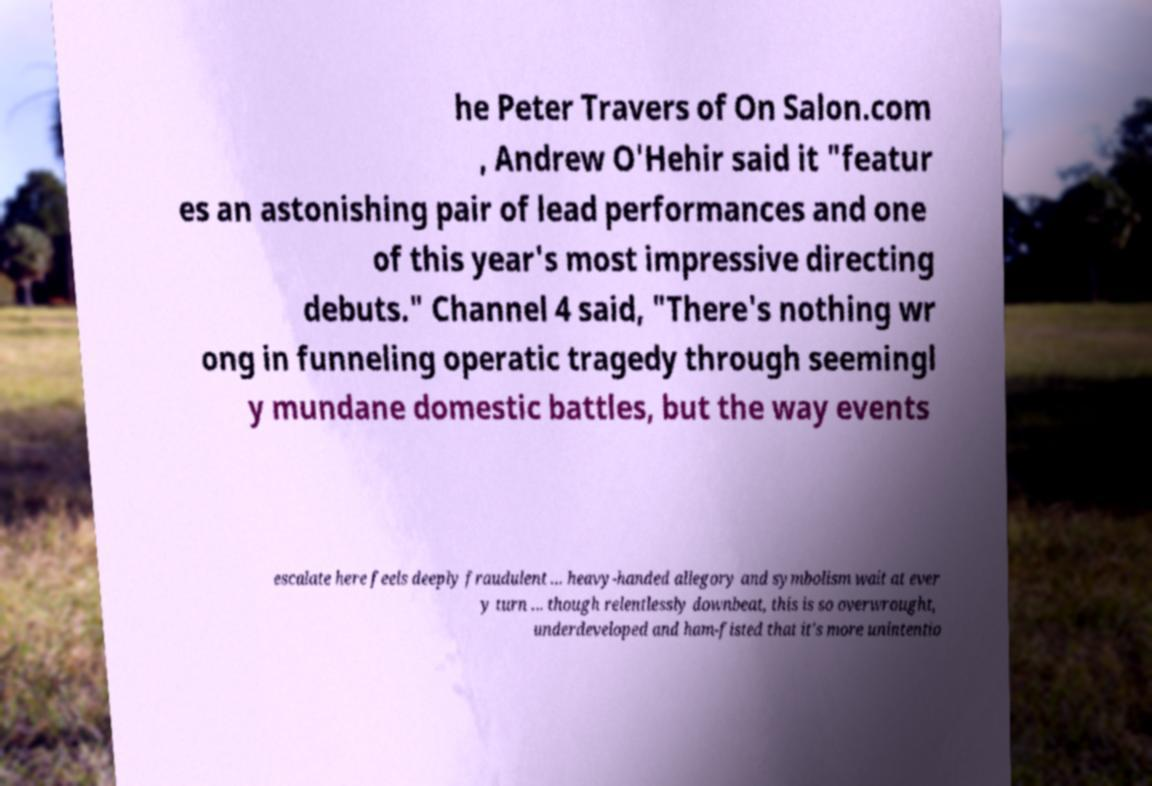Can you read and provide the text displayed in the image?This photo seems to have some interesting text. Can you extract and type it out for me? he Peter Travers of On Salon.com , Andrew O'Hehir said it "featur es an astonishing pair of lead performances and one of this year's most impressive directing debuts." Channel 4 said, "There's nothing wr ong in funneling operatic tragedy through seemingl y mundane domestic battles, but the way events escalate here feels deeply fraudulent ... heavy-handed allegory and symbolism wait at ever y turn ... though relentlessly downbeat, this is so overwrought, underdeveloped and ham-fisted that it's more unintentio 